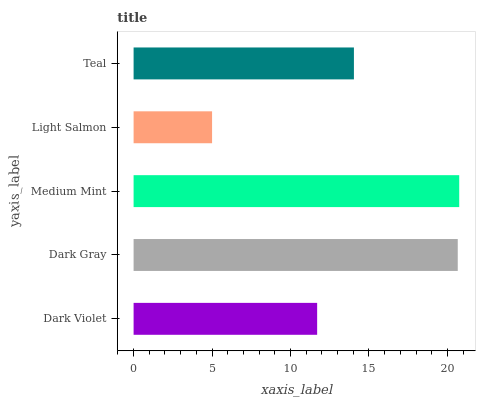Is Light Salmon the minimum?
Answer yes or no. Yes. Is Medium Mint the maximum?
Answer yes or no. Yes. Is Dark Gray the minimum?
Answer yes or no. No. Is Dark Gray the maximum?
Answer yes or no. No. Is Dark Gray greater than Dark Violet?
Answer yes or no. Yes. Is Dark Violet less than Dark Gray?
Answer yes or no. Yes. Is Dark Violet greater than Dark Gray?
Answer yes or no. No. Is Dark Gray less than Dark Violet?
Answer yes or no. No. Is Teal the high median?
Answer yes or no. Yes. Is Teal the low median?
Answer yes or no. Yes. Is Light Salmon the high median?
Answer yes or no. No. Is Medium Mint the low median?
Answer yes or no. No. 